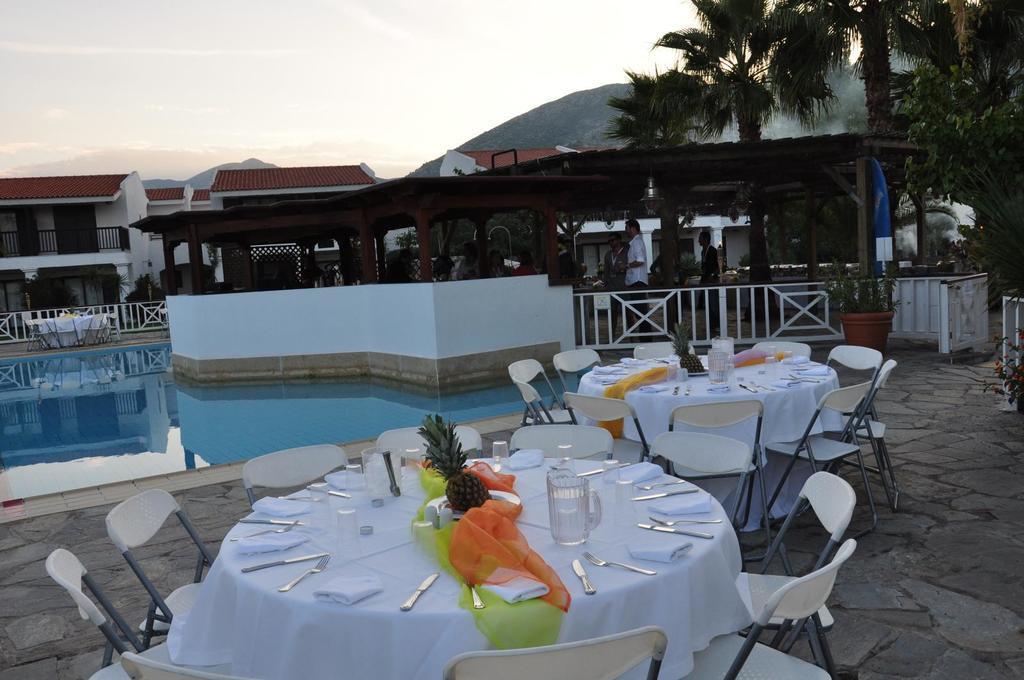Could you give a brief overview of what you see in this image? In this image I can see two tables and few chairs. On these tables I can see few glasses, knives and forks. In the background I can see few people, few trees and few buildings. Here I can see a swimming pool. 